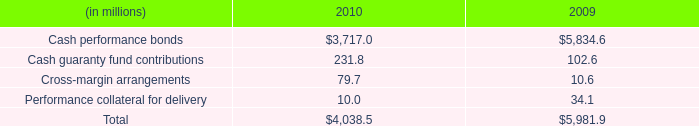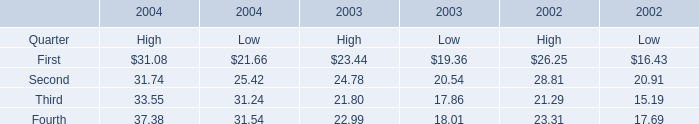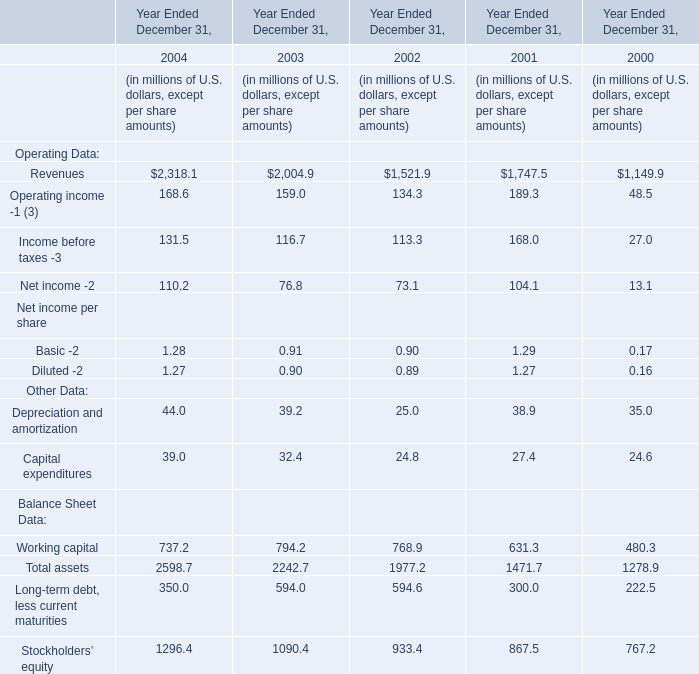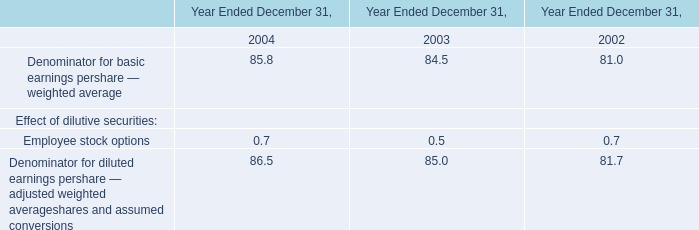What's the total amount of the elements for High in the years where Second for High is greater than 30? 
Computations: (((31.08 + 31.74) + 33.55) + 37.38)
Answer: 133.75. 